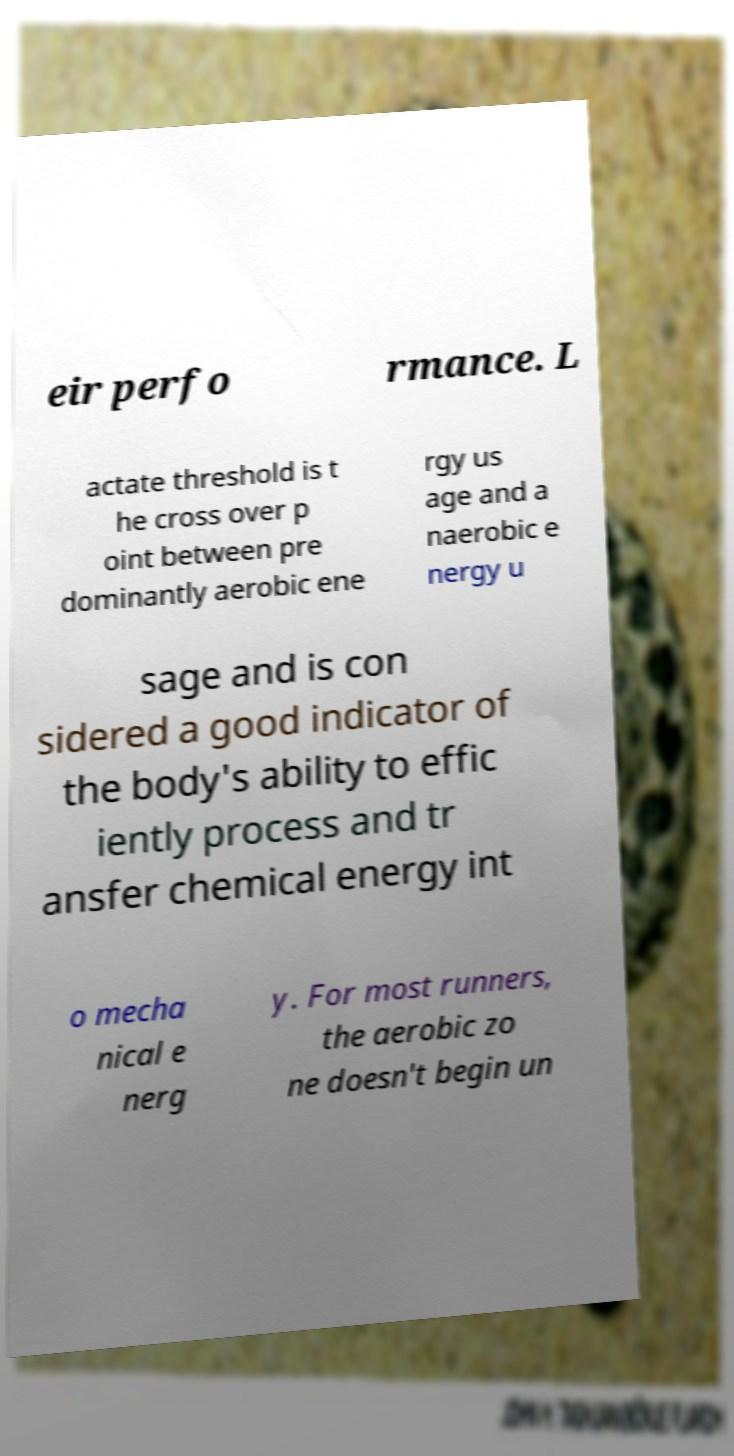For documentation purposes, I need the text within this image transcribed. Could you provide that? eir perfo rmance. L actate threshold is t he cross over p oint between pre dominantly aerobic ene rgy us age and a naerobic e nergy u sage and is con sidered a good indicator of the body's ability to effic iently process and tr ansfer chemical energy int o mecha nical e nerg y. For most runners, the aerobic zo ne doesn't begin un 